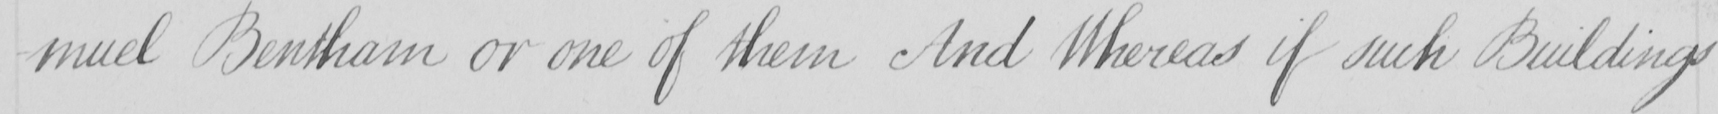What text is written in this handwritten line? -muel Bentham or one of them And Whereas if such Buildings 